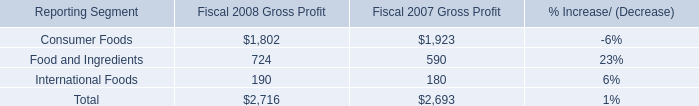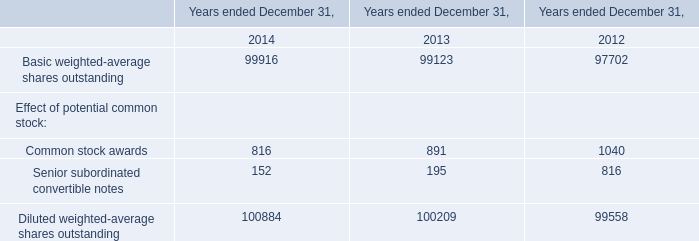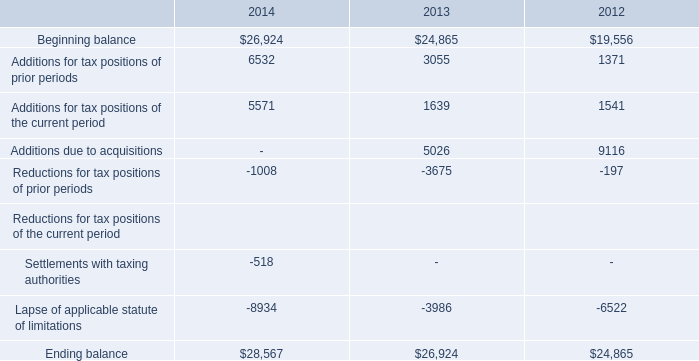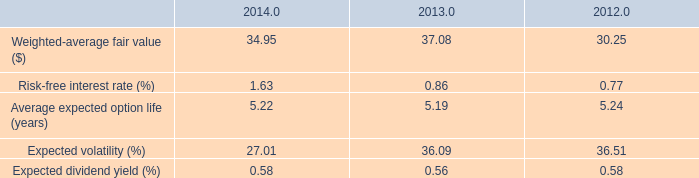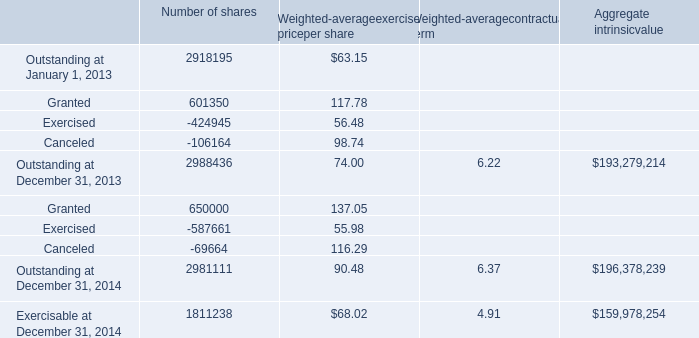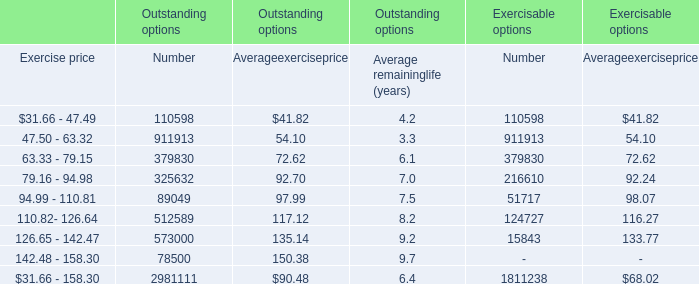What is the average value of Weighted-average fair value ($) in 2014, 2013, 2012? 
Computations: (((34.95 + 37.08) + 30.25) / 3)
Answer: 34.09333. 